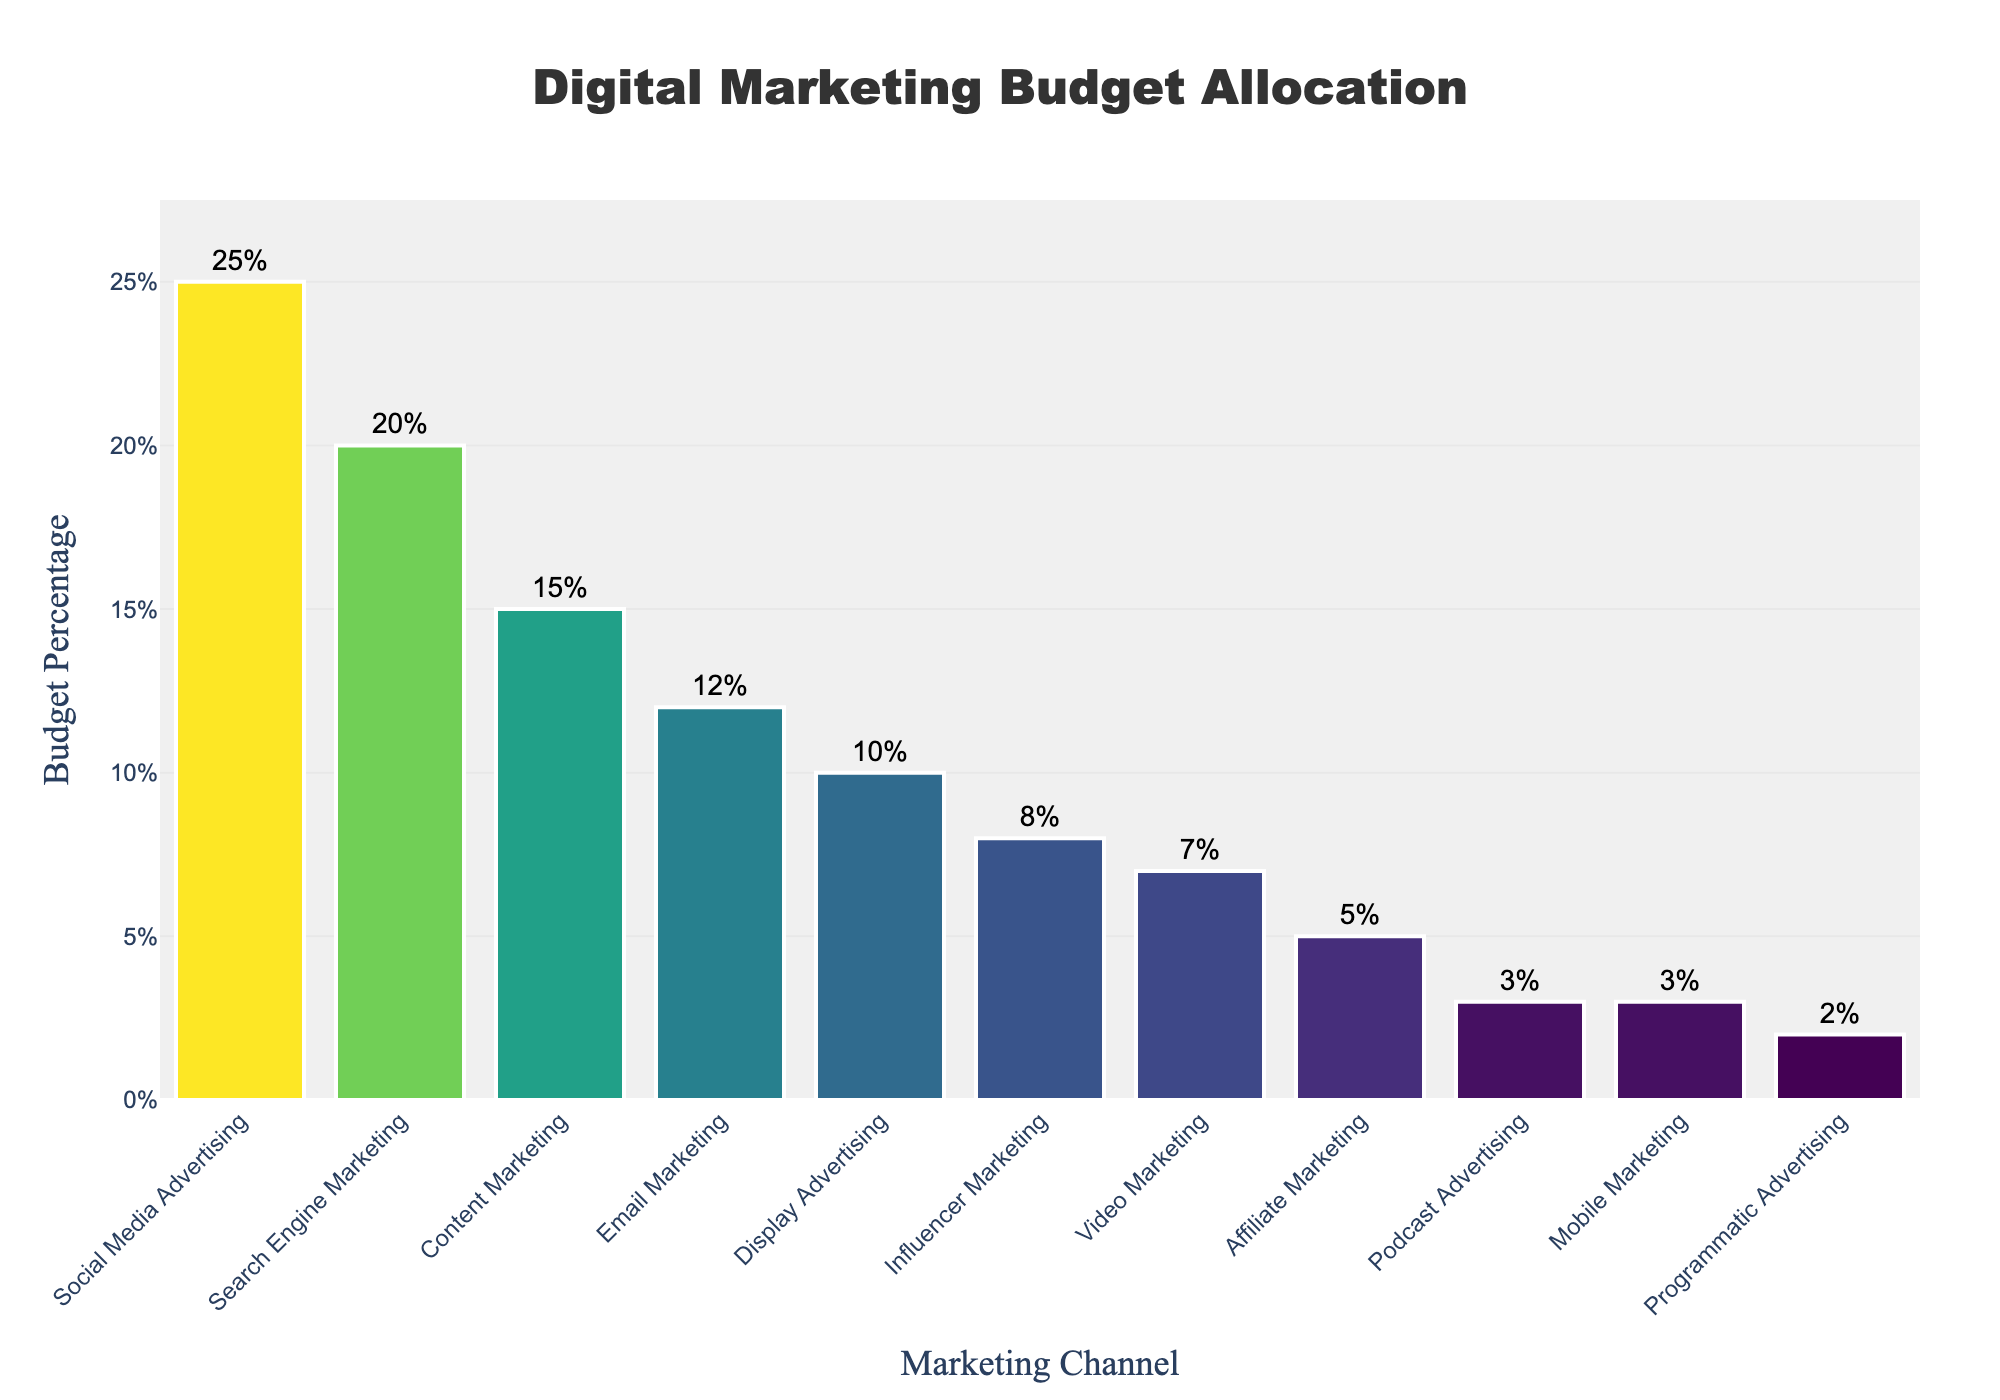What is the biggest single allocation in the digital marketing budget? By looking at the heights of the bars, the tallest bar represents the largest allocation. The Social Media Advertising bar is the tallest with a budget percentage of 25%.
Answer: 25% What is the total percentage allocated to Content Marketing and Email Marketing combined? Add the budget percentages of Content Marketing and Email Marketing. Content Marketing is 15% and Email Marketing is 12%, so 15% + 12% = 27%.
Answer: 27% Which channel has a larger budget percentage: Influencer Marketing or Video Marketing? Compare the heights of the bars for Influencer Marketing and Video Marketing. The Influencer Marketing bar is higher with 8%, compared to Video Marketing's 7%.
Answer: Influencer Marketing What is the cumulative budget percentage for all channels that are 10% or higher? Add the budget percentages of Social Media Advertising (25%), Search Engine Marketing (20%), Content Marketing (15%), and Email Marketing (12%). 25% + 20% + 15% + 12% = 72%.
Answer: 72% Which channel has the smallest budget allocation and what is its percentage? Look for the shortest bar on the chart. Programmatic Advertising has the shortest bar with a budget percentage of 2%.
Answer: Programmatic Advertising, 2% What is the difference in budget allocation between Search Engine Marketing and Display Advertising? Subtract the budget percentage of Display Advertising (10%) from Search Engine Marketing (20%). 20% - 10% = 10%.
Answer: 10% What is the average budget percentage of Social Media Advertising, Email Marketing, and Video Marketing? Add the budget percentages and divide by the number of channels: (25% + 12% + 7%)/3 = 44%/3 ≈ 14.67%.
Answer: 14.67% Which channels have a budget percentage lower than 5%? Identify all bars with a height representing less than 5%. These channels are Affiliate Marketing (5%), Podcast Advertising (3%), Mobile Marketing (3%), and Programmatic Advertising (2%).
Answer: Podcast Advertising, Mobile Marketing, Programmatic Advertising 